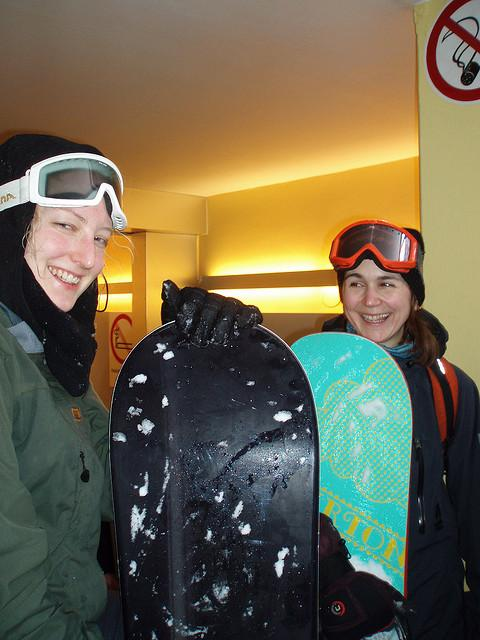What can't be done in this room? snowboard 